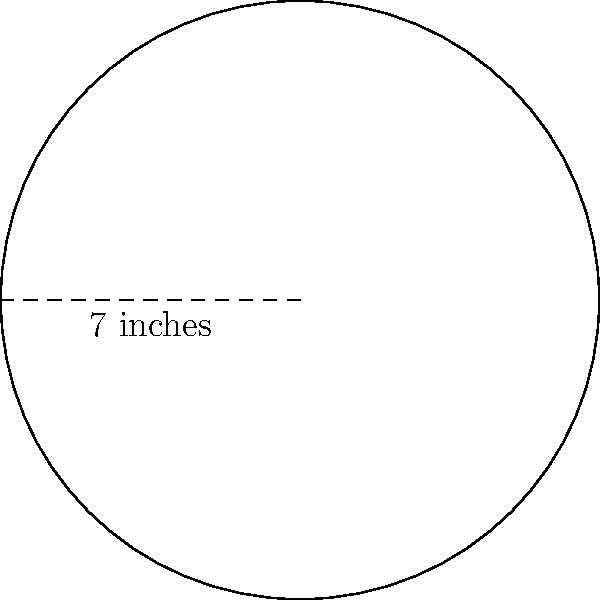You're baking a circular cake for your friends at school. The cake pan has a radius of 7 inches. What is the circumference of the cake pan? To find the circumference of a circular cake pan, we need to use the formula:

$$C = 2\pi r$$

Where:
$C$ = circumference
$\pi$ = pi (approximately 3.14159)
$r$ = radius

Given:
$r = 7$ inches

Step 1: Substitute the values into the formula
$$C = 2\pi(7)$$

Step 2: Multiply
$$C = 14\pi$$

Step 3: Calculate the final value (rounded to two decimal places)
$$C \approx 14 \times 3.14159 \approx 43.98 \text{ inches}$$

Therefore, the circumference of the cake pan is approximately 43.98 inches.
Answer: $43.98$ inches 